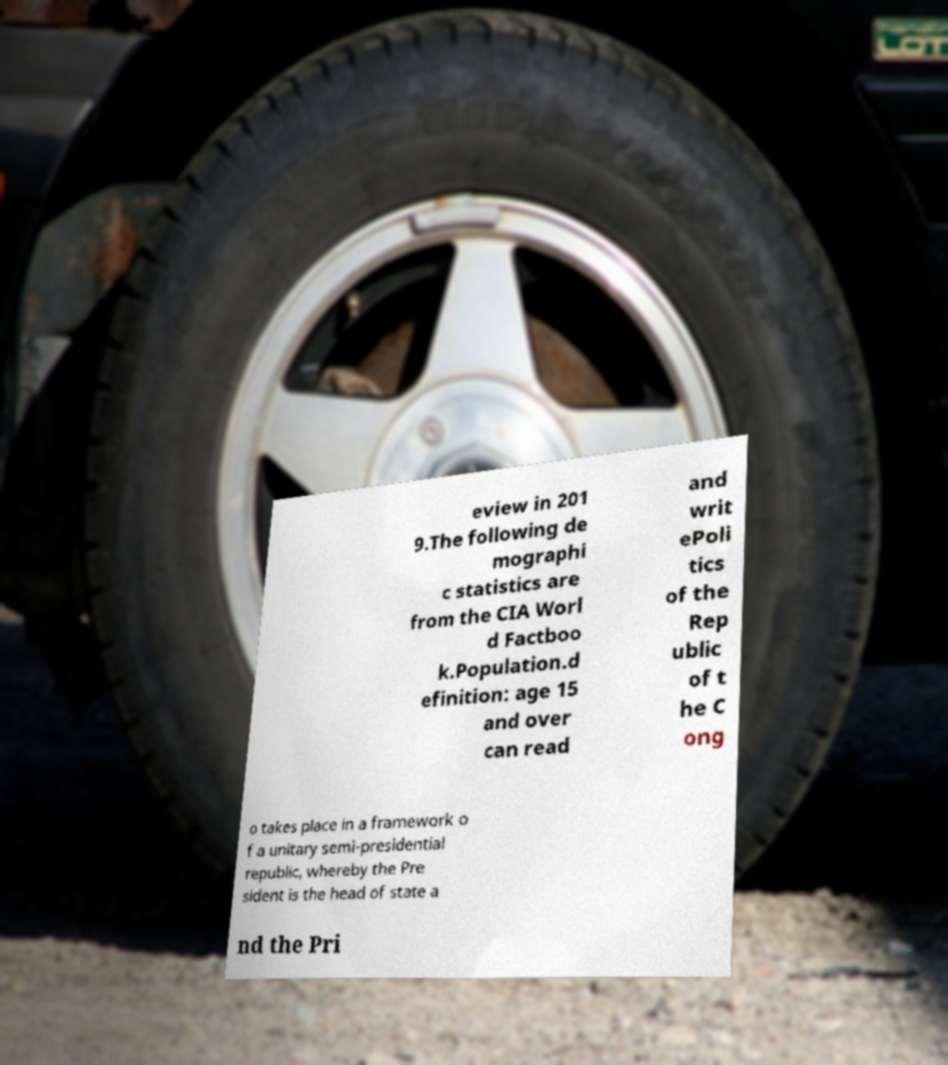For documentation purposes, I need the text within this image transcribed. Could you provide that? eview in 201 9.The following de mographi c statistics are from the CIA Worl d Factboo k.Population.d efinition: age 15 and over can read and writ ePoli tics of the Rep ublic of t he C ong o takes place in a framework o f a unitary semi-presidential republic, whereby the Pre sident is the head of state a nd the Pri 